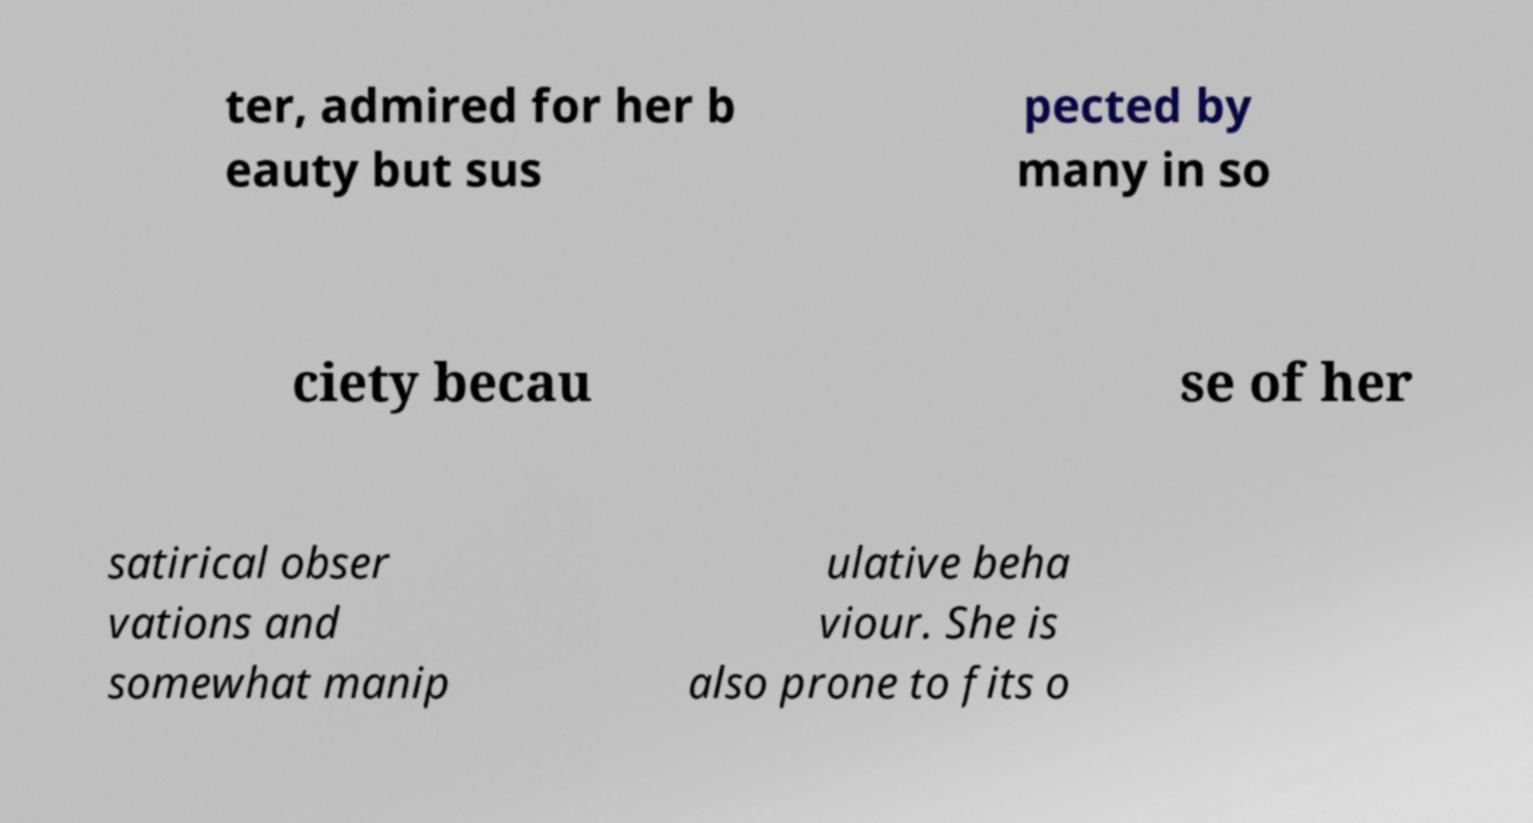I need the written content from this picture converted into text. Can you do that? ter, admired for her b eauty but sus pected by many in so ciety becau se of her satirical obser vations and somewhat manip ulative beha viour. She is also prone to fits o 